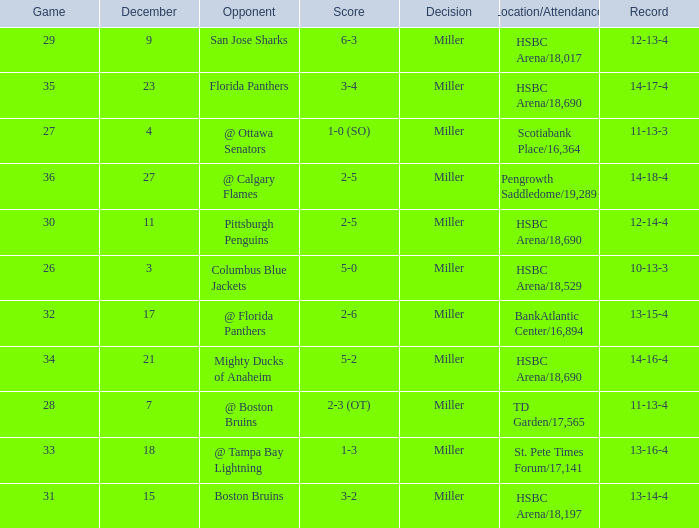Name the number of game 2-6 1.0. Would you be able to parse every entry in this table? {'header': ['Game', 'December', 'Opponent', 'Score', 'Decision', 'Location/Attendance', 'Record'], 'rows': [['29', '9', 'San Jose Sharks', '6-3', 'Miller', 'HSBC Arena/18,017', '12-13-4'], ['35', '23', 'Florida Panthers', '3-4', 'Miller', 'HSBC Arena/18,690', '14-17-4'], ['27', '4', '@ Ottawa Senators', '1-0 (SO)', 'Miller', 'Scotiabank Place/16,364', '11-13-3'], ['36', '27', '@ Calgary Flames', '2-5', 'Miller', 'Pengrowth Saddledome/19,289', '14-18-4'], ['30', '11', 'Pittsburgh Penguins', '2-5', 'Miller', 'HSBC Arena/18,690', '12-14-4'], ['26', '3', 'Columbus Blue Jackets', '5-0', 'Miller', 'HSBC Arena/18,529', '10-13-3'], ['32', '17', '@ Florida Panthers', '2-6', 'Miller', 'BankAtlantic Center/16,894', '13-15-4'], ['34', '21', 'Mighty Ducks of Anaheim', '5-2', 'Miller', 'HSBC Arena/18,690', '14-16-4'], ['28', '7', '@ Boston Bruins', '2-3 (OT)', 'Miller', 'TD Garden/17,565', '11-13-4'], ['33', '18', '@ Tampa Bay Lightning', '1-3', 'Miller', 'St. Pete Times Forum/17,141', '13-16-4'], ['31', '15', 'Boston Bruins', '3-2', 'Miller', 'HSBC Arena/18,197', '13-14-4']]} 